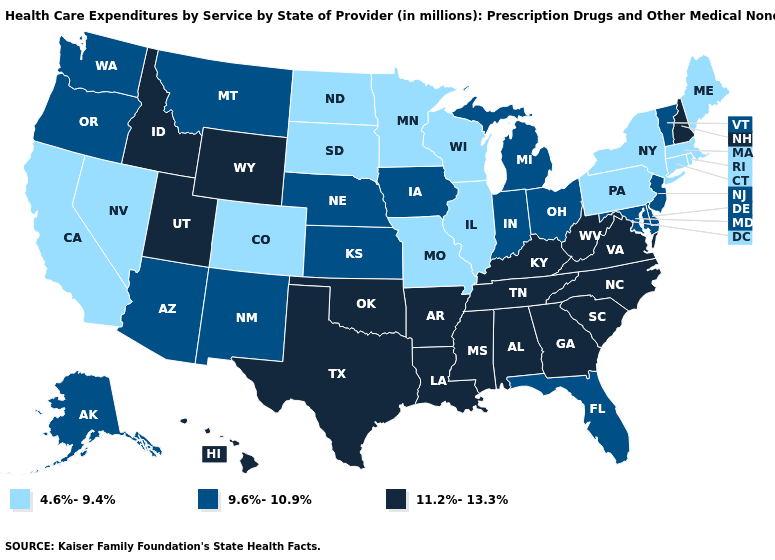Does Georgia have the lowest value in the USA?
Be succinct. No. What is the value of Michigan?
Short answer required. 9.6%-10.9%. Name the states that have a value in the range 4.6%-9.4%?
Quick response, please. California, Colorado, Connecticut, Illinois, Maine, Massachusetts, Minnesota, Missouri, Nevada, New York, North Dakota, Pennsylvania, Rhode Island, South Dakota, Wisconsin. Does Wyoming have the same value as South Carolina?
Write a very short answer. Yes. Which states have the highest value in the USA?
Write a very short answer. Alabama, Arkansas, Georgia, Hawaii, Idaho, Kentucky, Louisiana, Mississippi, New Hampshire, North Carolina, Oklahoma, South Carolina, Tennessee, Texas, Utah, Virginia, West Virginia, Wyoming. Which states have the lowest value in the Northeast?
Short answer required. Connecticut, Maine, Massachusetts, New York, Pennsylvania, Rhode Island. Among the states that border Illinois , which have the highest value?
Short answer required. Kentucky. What is the value of Delaware?
Give a very brief answer. 9.6%-10.9%. Among the states that border Kentucky , which have the highest value?
Short answer required. Tennessee, Virginia, West Virginia. Which states have the highest value in the USA?
Concise answer only. Alabama, Arkansas, Georgia, Hawaii, Idaho, Kentucky, Louisiana, Mississippi, New Hampshire, North Carolina, Oklahoma, South Carolina, Tennessee, Texas, Utah, Virginia, West Virginia, Wyoming. What is the highest value in the USA?
Concise answer only. 11.2%-13.3%. What is the value of Maine?
Write a very short answer. 4.6%-9.4%. What is the highest value in the USA?
Write a very short answer. 11.2%-13.3%. What is the value of Minnesota?
Give a very brief answer. 4.6%-9.4%. Does Ohio have the same value as Vermont?
Concise answer only. Yes. 